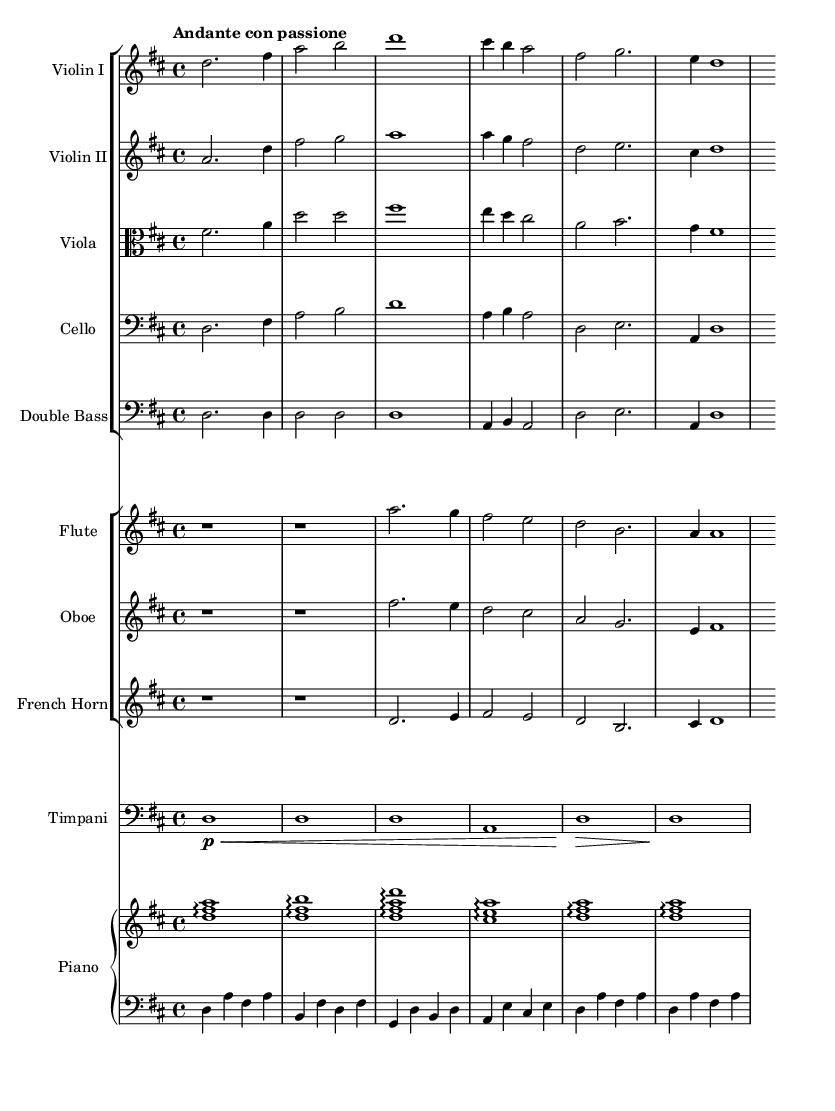What is the key signature of this music? The key signature is indicated at the beginning of the score, and it shows two sharps, which corresponds to the key of D major.
Answer: D major What is the time signature of this music? The time signature is found at the beginning of the score, showing a "4/4" time signature. This indicates that there are four beats in each measure, and the quarter note gets one beat.
Answer: 4/4 What is the tempo marking of this piece? The tempo marking "Andante con passione" is located at the beginning of the score. "Andante" indicates a moderately slow pace, and "con passione" suggests that it should be played with passion.
Answer: Andante con passione Which instruments are playing the theme together? The instruments playing together can be determined by looking at the parts that align vertically within the score. The first violin, second violin, viola, cello, and double bass are all part of the same staff group, indicating they are playing together.
Answer: Violin I, Violin II, Viola, Cello, Double Bass What is the role of the piano in this piece? The piano has two staves, one for the right hand and one for the left hand, which indicates that it has a melodic and harmonic role. The right hand plays arpeggiated chords while the left hand supports with bass notes. This structure enhances the romantic quality of the music.
Answer: Melodic and harmonic role What is the harmonic structure of the piece? To determine the harmonic structure, analyze the chords played by the piano and the bass lines. The piece features triadic harmonies predominantly within the key of D major, typical of Romantic orchestral music, adding emotional depth.
Answer: Triadic harmonies in D major How does the instrumentation contribute to the romantic feel of the music? The instrumentation includes strings, woodwinds, brass, and piano, which together create a rich and immersive soundscape. Strings convey warmth, while woodwinds add lyricism, brass brings power, and piano provides harmonic richness, all typical of Romantic orchestral textures.
Answer: Rich and immersive soundscape 